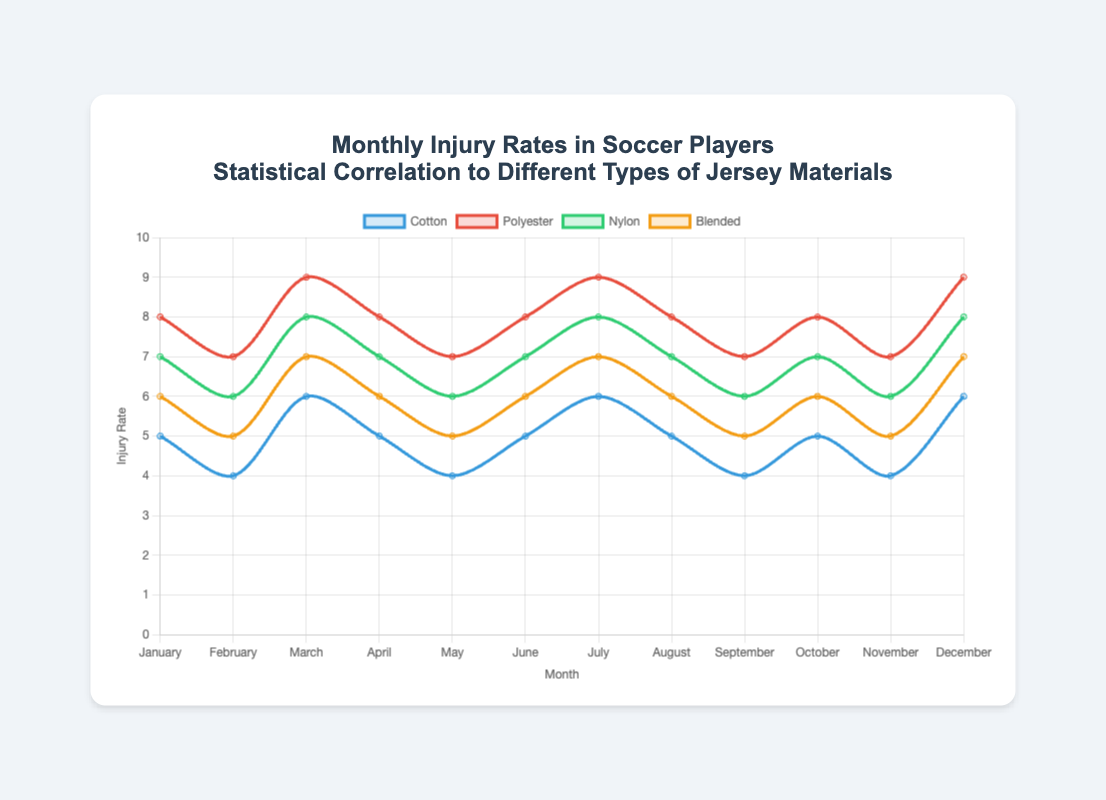What is the average injury rate for Polyester jerseys over the year? To find the average, sum all the injury rates for Polyester jerseys and then divide by the number of months. The sum is (8 + 7 + 9 + 8 + 7 + 8 + 9 + 8 + 7 + 8 + 7 + 9) = 95, and there are 12 months. So, the average is 95/12.
Answer: 7.92 Which month has the highest injury rate for Nylon jerseys? By inspecting the chart, we can see that March, July, and December all have the highest injury rates for Nylon jerseys, which are 8.
Answer: March, July, December In which months are the injury rates equal for Cotton and Blended jerseys? By looking at the chart, we see that in January, April, June, August, October, and December, the injury rates for Cotton and Blended jerseys are equal.
Answer: January, April, June, August, October, December What is the total injury rate for Cotton and Blended jerseys in July? Add the injury rates for both Cotton and Blended jerseys in July. Cotton has 6 and Blended has 7. Therefore, the total is 6 + 7.
Answer: 13 By how much does the injury rate for Polyester jerseys in November exceed that of Cotton jerseys in the same month? The injury rate for Polyester jerseys in November is 7, while for Cotton jerseys, it is 4. So, the difference is 7 - 4.
Answer: 3 Which jersey type consistently has the highest injury rates each month? By examining the chart, Polyester consistently has the highest injury rates each month.
Answer: Polyester What is the percentage increase in injury rates for Nylon jerseys from February to March? First find the injury rates for February (6) and March (8). The increase is 8 - 6 = 2. To find the percentage increase, (2/6) * 100 = 33.33%.
Answer: 33.33% What's the median injury rate for Nylon jerseys across the year? List all rates for Nylon (7, 6, 8, 7, 6, 7, 8, 7, 6, 7, 6, 8). When sorted (6, 6, 6, 6, 7, 7, 7, 7, 7, 7, 8, 8), the middle values are 7 and 7, and their average is 7.
Answer: 7 How does the injury rate of Blended jerseys in May compare to that of Cotton jerseys in the same month? In May, the injury rate for Blended jerseys is 5, while that for Cotton jerseys is also 4, so Blended has a higher injury rate.
Answer: Blended higher by 1 Which jersey type shows the least variation in injury rates throughout the year? By looking at the range of injury rates, Cotton varies between 4 and 6, showing the least variation compared to others.
Answer: Cotton 